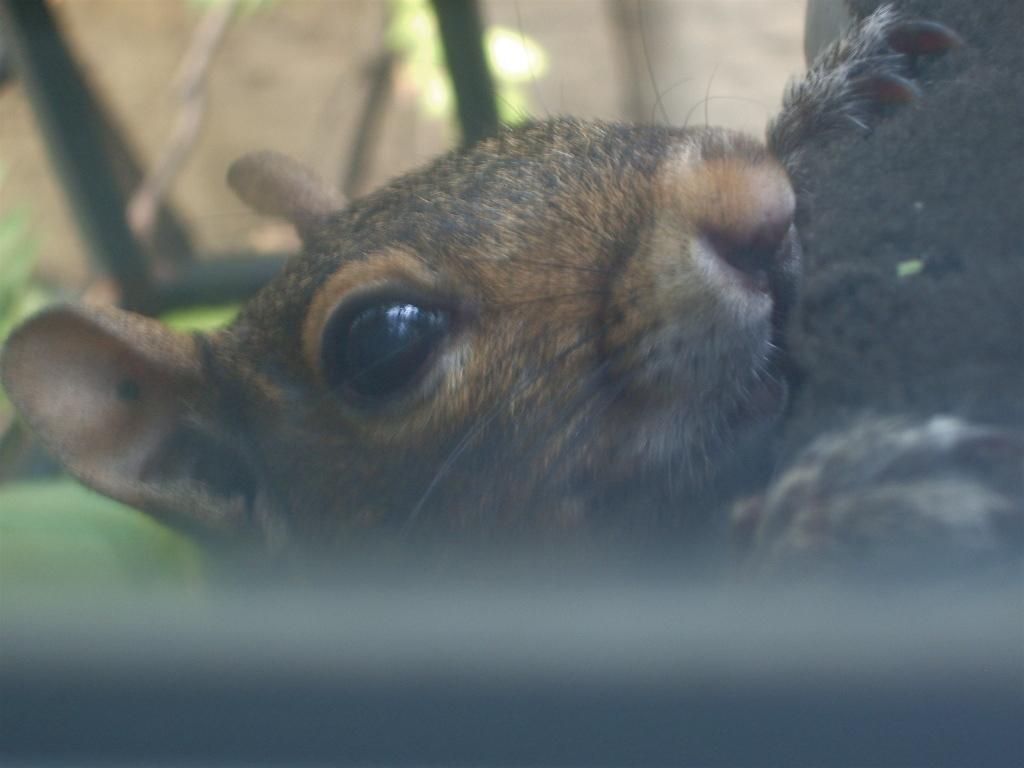Describe this image in one or two sentences. In the picture we can see a face of a rat with eye, ears, nose and two hands with nails and behind the rat we can see some plant which is not clearly visible. 